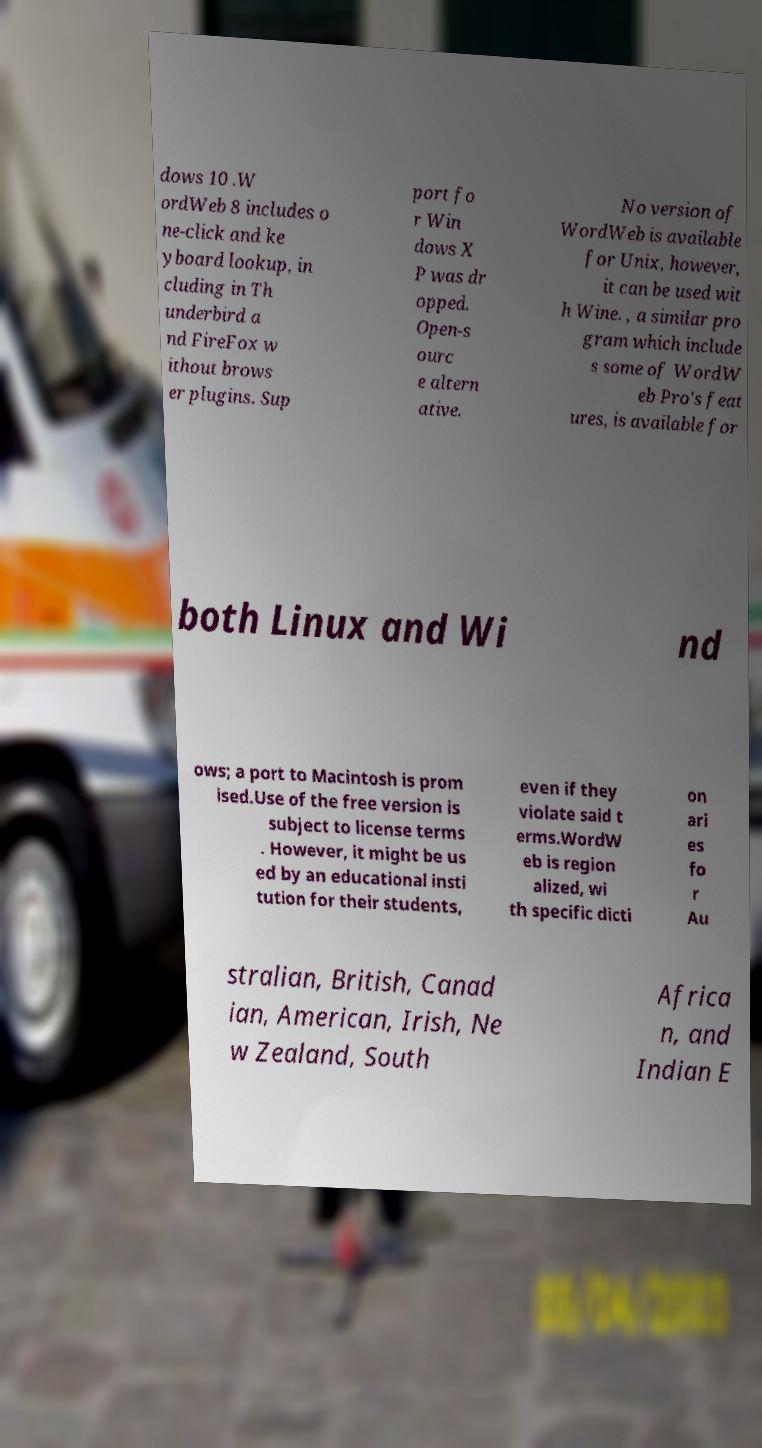There's text embedded in this image that I need extracted. Can you transcribe it verbatim? dows 10 .W ordWeb 8 includes o ne-click and ke yboard lookup, in cluding in Th underbird a nd FireFox w ithout brows er plugins. Sup port fo r Win dows X P was dr opped. Open-s ourc e altern ative. No version of WordWeb is available for Unix, however, it can be used wit h Wine. , a similar pro gram which include s some of WordW eb Pro's feat ures, is available for both Linux and Wi nd ows; a port to Macintosh is prom ised.Use of the free version is subject to license terms . However, it might be us ed by an educational insti tution for their students, even if they violate said t erms.WordW eb is region alized, wi th specific dicti on ari es fo r Au stralian, British, Canad ian, American, Irish, Ne w Zealand, South Africa n, and Indian E 